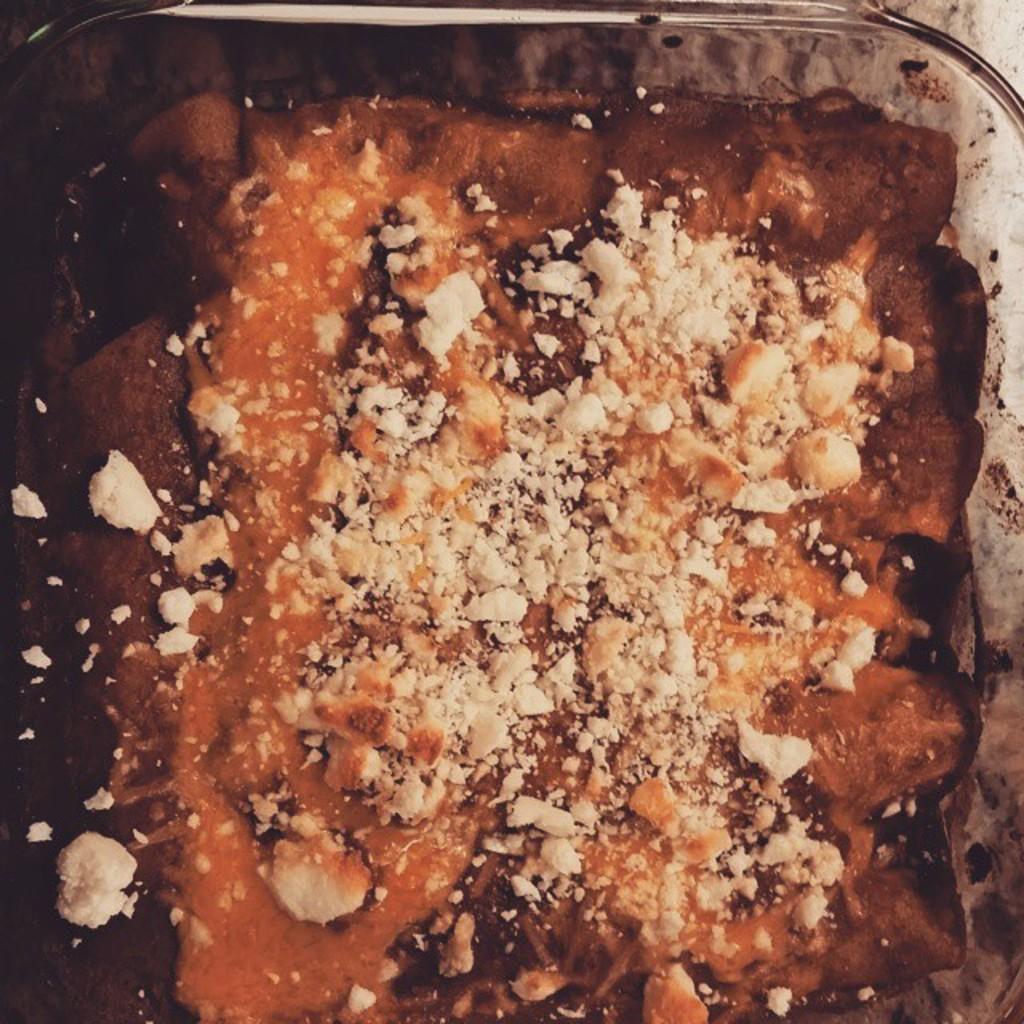Please provide a concise description of this image. There is a food item on a glass vessel. On the food item there are some white color things. 